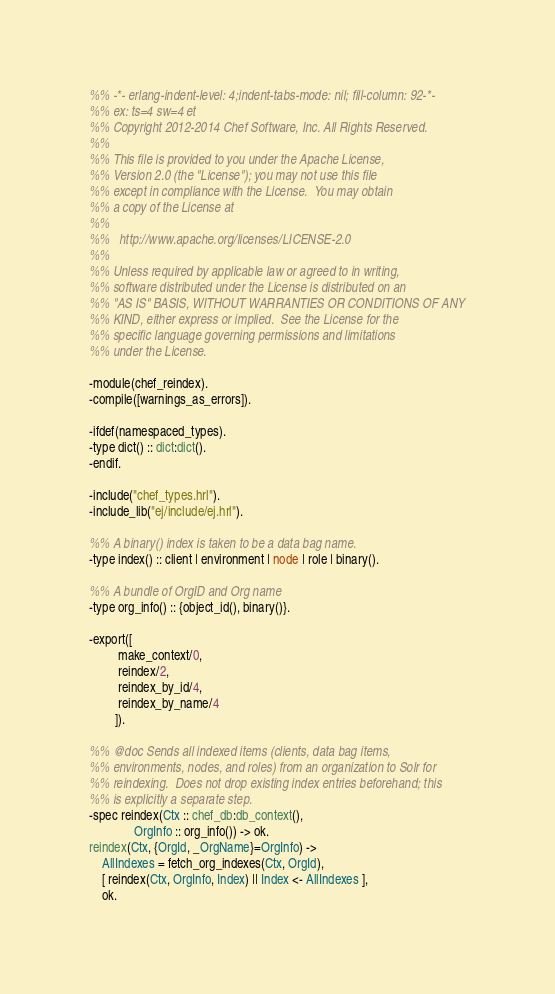<code> <loc_0><loc_0><loc_500><loc_500><_Erlang_>%% -*- erlang-indent-level: 4;indent-tabs-mode: nil; fill-column: 92-*-
%% ex: ts=4 sw=4 et
%% Copyright 2012-2014 Chef Software, Inc. All Rights Reserved.
%%
%% This file is provided to you under the Apache License,
%% Version 2.0 (the "License"); you may not use this file
%% except in compliance with the License.  You may obtain
%% a copy of the License at
%%
%%   http://www.apache.org/licenses/LICENSE-2.0
%%
%% Unless required by applicable law or agreed to in writing,
%% software distributed under the License is distributed on an
%% "AS IS" BASIS, WITHOUT WARRANTIES OR CONDITIONS OF ANY
%% KIND, either express or implied.  See the License for the
%% specific language governing permissions and limitations
%% under the License.

-module(chef_reindex).
-compile([warnings_as_errors]).

-ifdef(namespaced_types).
-type dict() :: dict:dict().
-endif.

-include("chef_types.hrl").
-include_lib("ej/include/ej.hrl").

%% A binary() index is taken to be a data bag name.
-type index() :: client | environment | node | role | binary().

%% A bundle of OrgID and Org name
-type org_info() :: {object_id(), binary()}.

-export([
         make_context/0,
         reindex/2,
         reindex_by_id/4,
         reindex_by_name/4
        ]).

%% @doc Sends all indexed items (clients, data bag items,
%% environments, nodes, and roles) from an organization to Solr for
%% reindexing.  Does not drop existing index entries beforehand; this
%% is explicitly a separate step.
-spec reindex(Ctx :: chef_db:db_context(),
              OrgInfo :: org_info()) -> ok.
reindex(Ctx, {OrgId, _OrgName}=OrgInfo) ->
    AllIndexes = fetch_org_indexes(Ctx, OrgId),
    [ reindex(Ctx, OrgInfo, Index) || Index <- AllIndexes ],
    ok.
</code> 